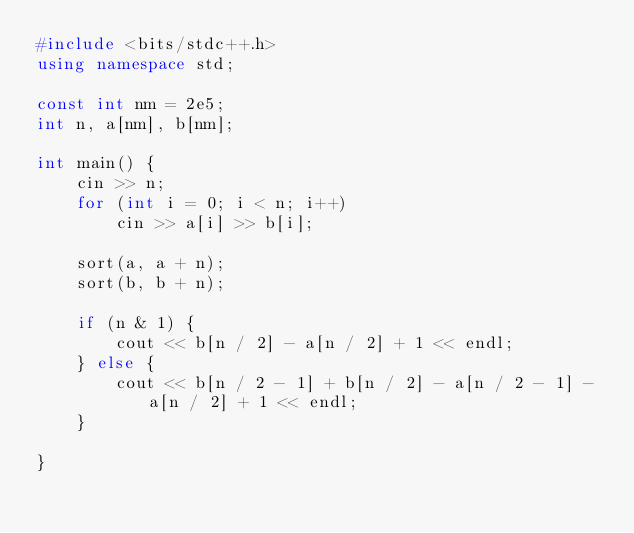<code> <loc_0><loc_0><loc_500><loc_500><_C++_>#include <bits/stdc++.h>
using namespace std;

const int nm = 2e5;
int n, a[nm], b[nm];

int main() {
	cin >> n;
	for (int i = 0; i < n; i++)
		cin >> a[i] >> b[i];

	sort(a, a + n);
	sort(b, b + n);

	if (n & 1) {
		cout << b[n / 2] - a[n / 2] + 1 << endl;
	} else {
		cout << b[n / 2 - 1] + b[n / 2] - a[n / 2 - 1] - a[n / 2] + 1 << endl;
	}

}
</code> 